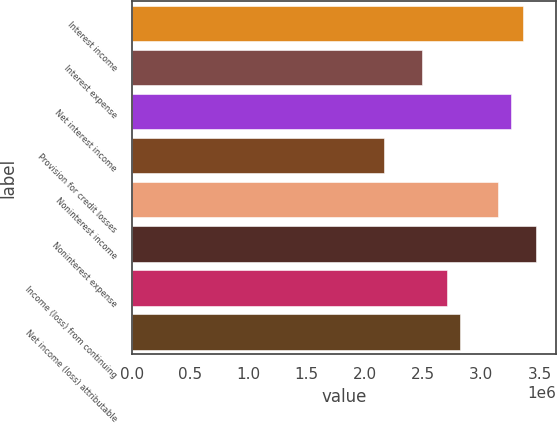Convert chart. <chart><loc_0><loc_0><loc_500><loc_500><bar_chart><fcel>Interest income<fcel>Interest expense<fcel>Net interest income<fcel>Provision for credit losses<fcel>Noninterest income<fcel>Noninterest expense<fcel>Income (loss) from continuing<fcel>Net income (loss) attributable<nl><fcel>3.35952e+06<fcel>2.49255e+06<fcel>3.25115e+06<fcel>2.16743e+06<fcel>3.14278e+06<fcel>3.46789e+06<fcel>2.70929e+06<fcel>2.81766e+06<nl></chart> 